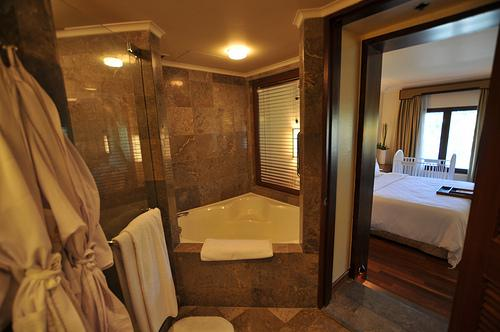Question: what is on the window in the bathroom?
Choices:
A. Stensils.
B. Stickers.
C. Curtains.
D. Blinds.
Answer with the letter. Answer: D Question: where was this picture taken?
Choices:
A. A bedroom.
B. A bathroom.
C. A toy room.
D. A Art room.
Answer with the letter. Answer: B Question: how many bathrobes are hanging on the wall?
Choices:
A. One.
B. Three.
C. Two.
D. Four.
Answer with the letter. Answer: C 